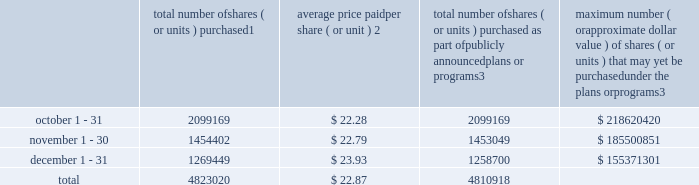Sales of unregistered securities not applicable .
Repurchase of equity securities the table provides information regarding our purchases of our equity securities during the period from october 1 , 2016 to december 31 , 2016 .
Total number of shares ( or units ) purchased 1 average price paid per share ( or unit ) 2 total number of shares ( or units ) purchased as part of publicly announced plans or programs 3 maximum number ( or approximate dollar value ) of shares ( or units ) that may yet be purchased under the plans or programs 3 .
1 included shares of our common stock , par value $ 0.10 per share , withheld under the terms of grants under employee stock-based compensation plans to offset tax withholding obligations that occurred upon vesting and release of restricted shares ( the 201cwithheld shares 201d ) .
We repurchased no withheld shares in october 2016 , 1353 withheld shares in november 2016 and 10749 withheld shares in december 2016 , for a total of 12102 withheld shares during the three-month period .
2 the average price per share for each of the months in the fiscal quarter and for the three-month period was calculated by dividing the sum of the applicable period of the aggregate value of the tax withholding obligations and the aggregate amount we paid for shares acquired under our share repurchase program , described in note 5 to the consolidated financial statements , by the sum of the number of withheld shares and the number of shares acquired in our share repurchase program .
3 in february 2016 , the board authorized a share repurchase program to repurchase from time to time up to $ 300.0 million , excluding fees , of our common stock ( the 201c2016 share repurchase program 201d ) .
On february 10 , 2017 , we announced that our board had approved a new share repurchase program to repurchase from time to time up to $ 300.0 million , excluding fees , of our common stock .
The new authorization is in addition to any amounts remaining for repurchase under the 2016 share repurchase program .
There is no expiration date associated with the share repurchase programs. .
How is the treasury stock affected after the stock repurchases in the last three months of 2016 , ( in millions ) ? 
Computations: ((4823020 * 22.87) / 1000000)
Answer: 110.30247. 